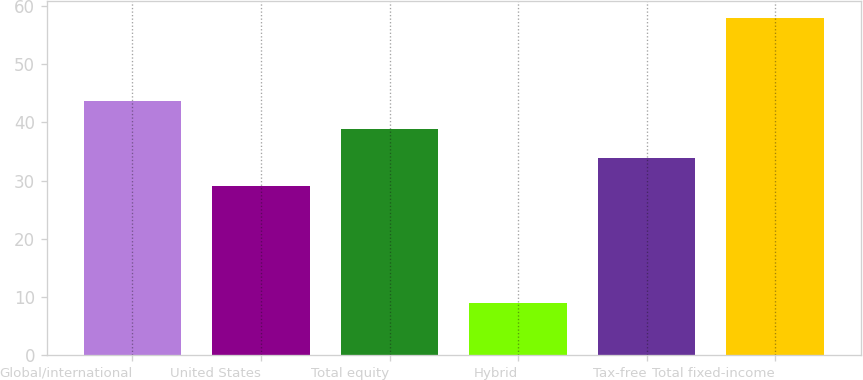Convert chart. <chart><loc_0><loc_0><loc_500><loc_500><bar_chart><fcel>Global/international<fcel>United States<fcel>Total equity<fcel>Hybrid<fcel>Tax-free<fcel>Total fixed-income<nl><fcel>43.7<fcel>29<fcel>38.8<fcel>9<fcel>33.9<fcel>58<nl></chart> 